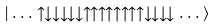<formula> <loc_0><loc_0><loc_500><loc_500>| \dots \uparrow \downarrow \downarrow \downarrow \downarrow \downarrow \uparrow \uparrow \uparrow \uparrow \uparrow \uparrow \uparrow \uparrow \downarrow \downarrow \downarrow \downarrow \dots \rangle</formula> 